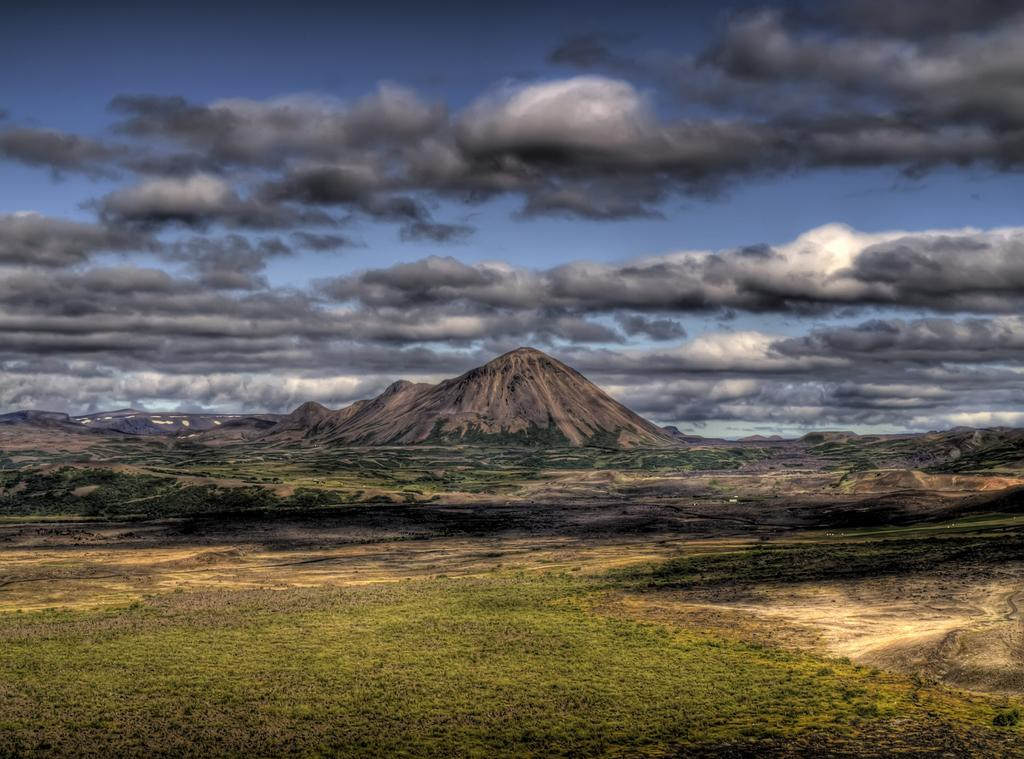What type of terrain is visible in the image? There is land visible in the image. What geographical feature can be seen in the image? There is a mountain in the image. How would you describe the sky in the image? The sky is blue with black clouds. What type of ball is being played with in the image? There is no ball present in the image. Can you describe the scent of the goldfish in the image? There is no goldfish present in the image, so it is not possible to describe its scent. 